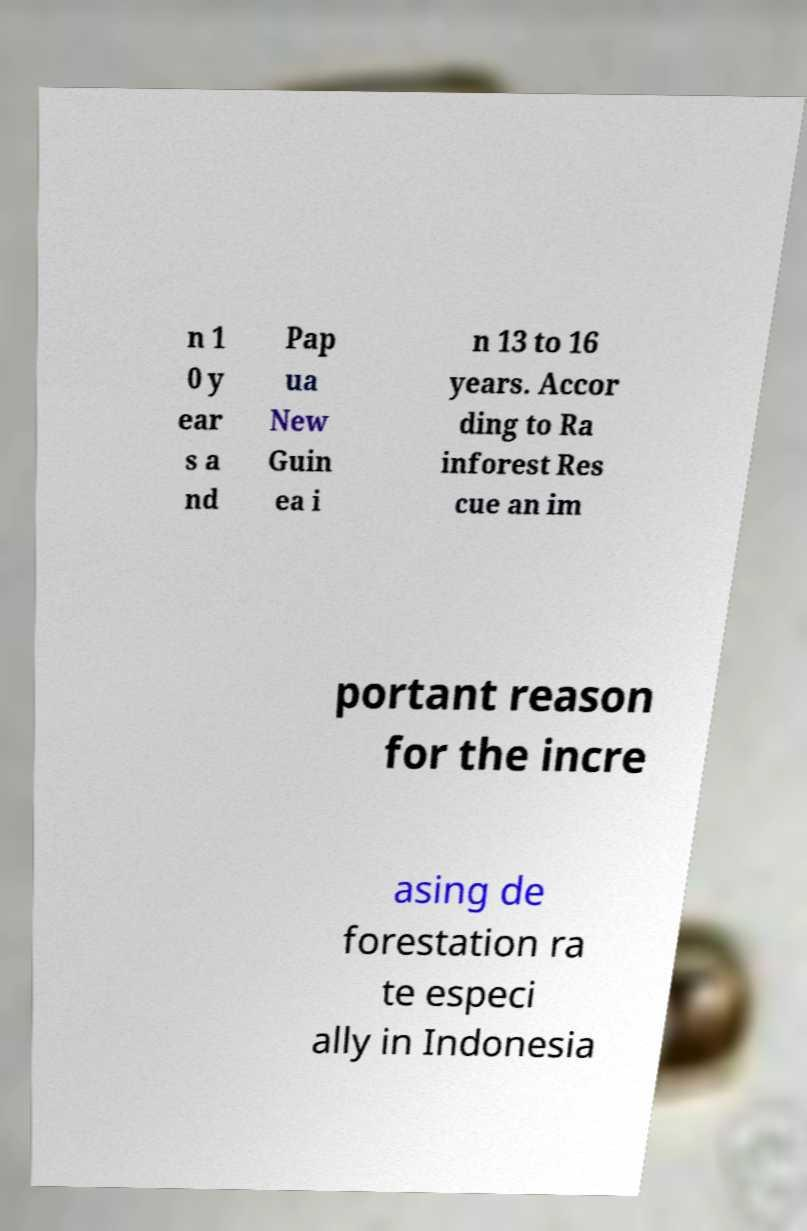For documentation purposes, I need the text within this image transcribed. Could you provide that? n 1 0 y ear s a nd Pap ua New Guin ea i n 13 to 16 years. Accor ding to Ra inforest Res cue an im portant reason for the incre asing de forestation ra te especi ally in Indonesia 